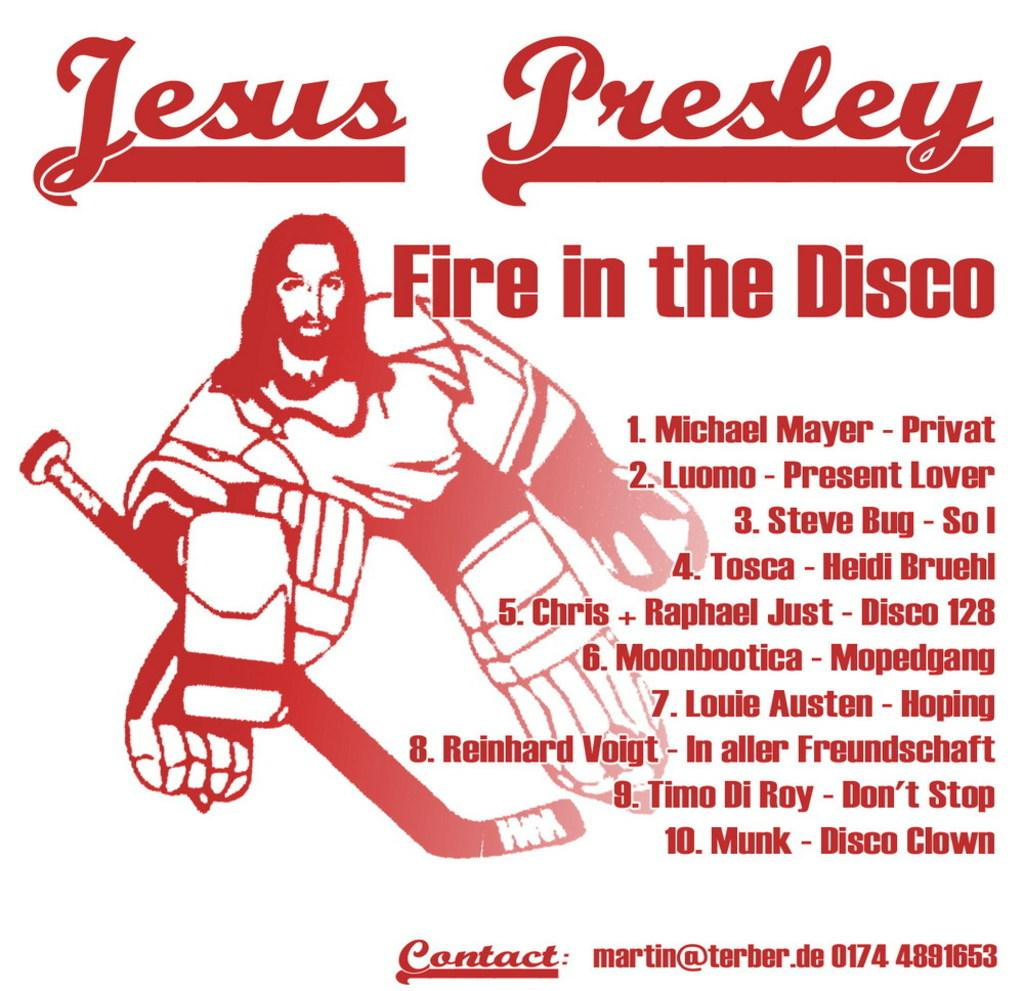<image>
Create a compact narrative representing the image presented. a poster fire in the disco with jesus as a goalie 